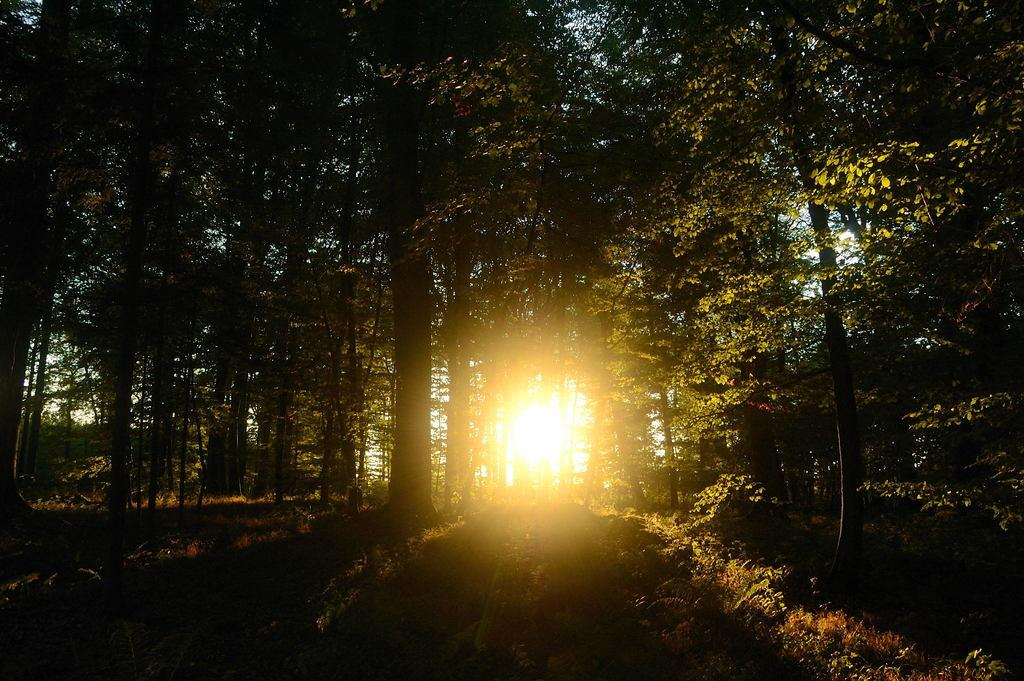What celestial body can be seen in the image? The sun is visible in the image. What else is visible in the sky besides the sun? The sky is visible in the image. What type of vegetation can be seen in the image? There are trees and plants visible in the image. What is the ground covered with in the image? There is grass visible in the image. Can you see a nest made of steel in the image? There is no nest, let alone a steel nest, present in the image. 